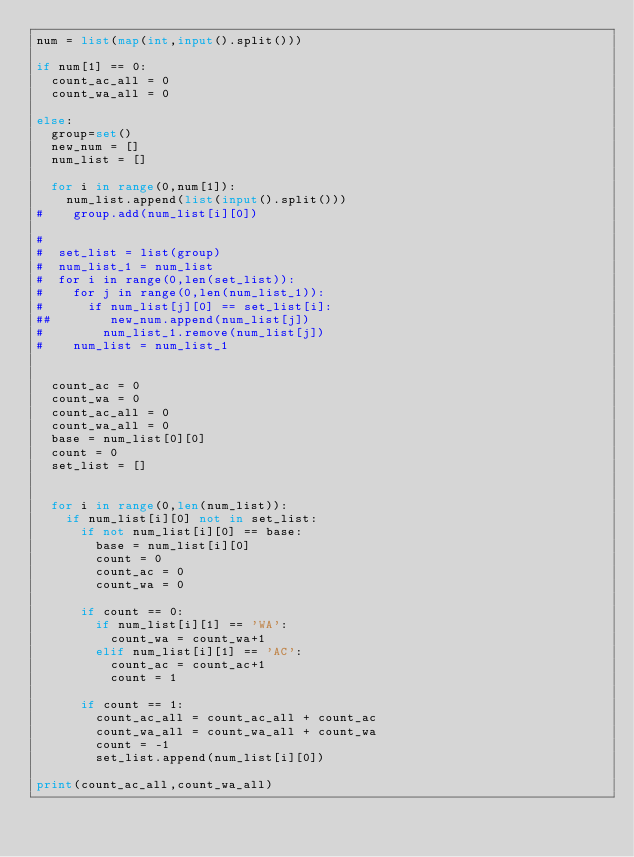Convert code to text. <code><loc_0><loc_0><loc_500><loc_500><_Python_>num = list(map(int,input().split()))

if num[1] == 0:     
  count_ac_all = 0
  count_wa_all = 0 
  
else:  
  group=set()
  new_num = []
  num_list = []
  
  for i in range(0,num[1]):
    num_list.append(list(input().split()))
#    group.add(num_list[i][0])
    
#
#  set_list = list(group)
#  num_list_1 = num_list
#  for i in range(0,len(set_list)):
#    for j in range(0,len(num_list_1)):
#      if num_list[j][0] == set_list[i]:
##        new_num.append(num_list[j])
#        num_list_1.remove(num_list[j])
#    num_list = num_list_1


  count_ac = 0
  count_wa = 0
  count_ac_all = 0
  count_wa_all = 0
  base = num_list[0][0]
  count = 0
  set_list = []


  for i in range(0,len(num_list)):
    if num_list[i][0] not in set_list:
      if not num_list[i][0] == base:
        base = num_list[i][0]
        count = 0
        count_ac = 0
        count_wa = 0

      if count == 0:
        if num_list[i][1] == 'WA':
          count_wa = count_wa+1
        elif num_list[i][1] == 'AC':
          count_ac = count_ac+1
          count = 1

      if count == 1:
        count_ac_all = count_ac_all + count_ac
        count_wa_all = count_wa_all + count_wa
        count = -1
        set_list.append(num_list[i][0])

print(count_ac_all,count_wa_all)</code> 